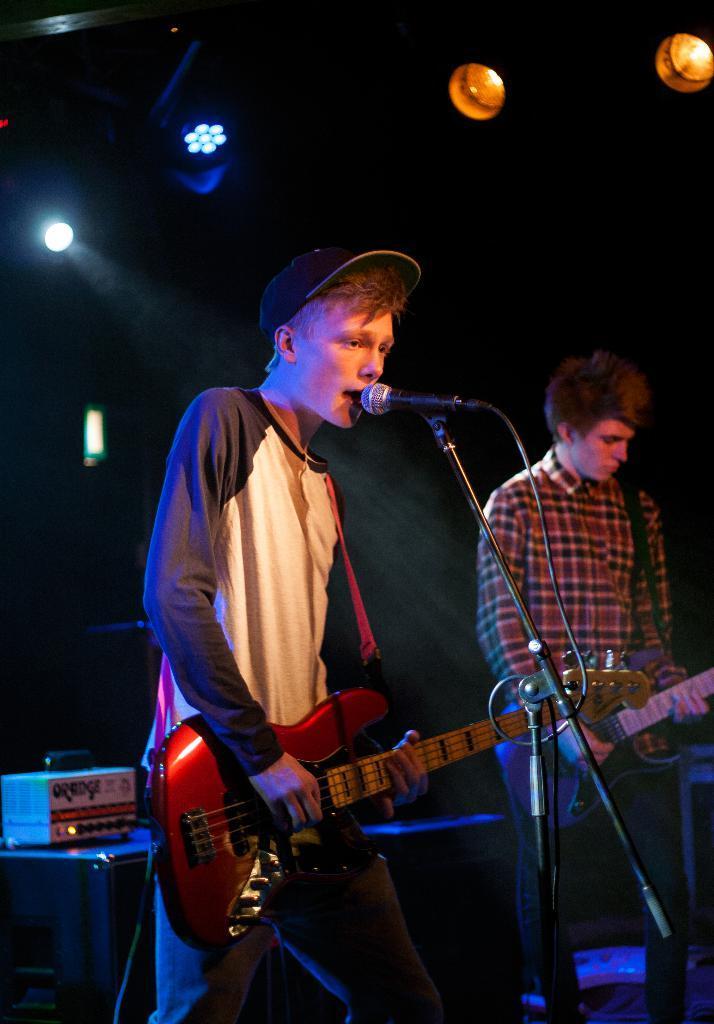How would you summarize this image in a sentence or two? In the middle of the image two persons are playing guitar and there is a microphone. Behind them there are some electronic devices. At the top of the image there are some lights. 